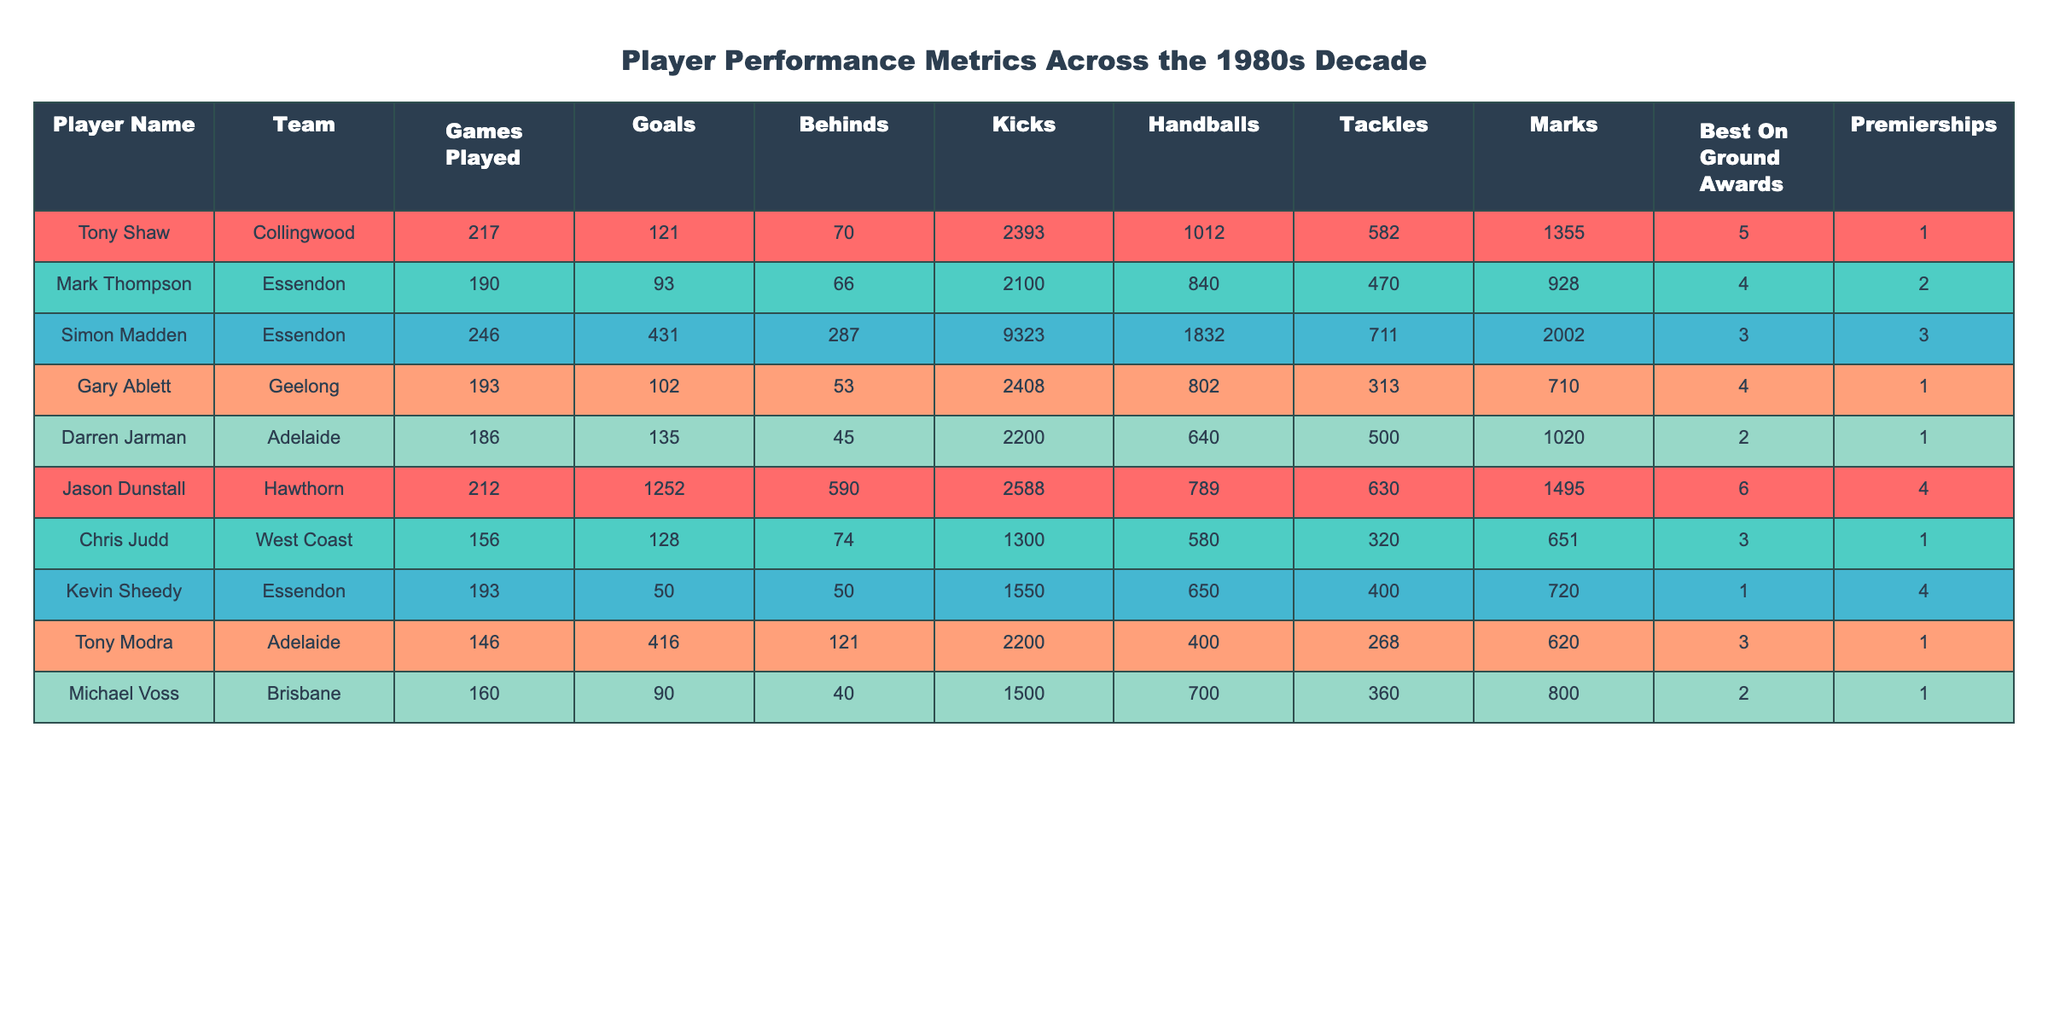What is the player name with the highest number of goals? By checking the "Goals" column, we see that Simon Madden has 431 goals, which is more than any other player listed in the table.
Answer: Simon Madden How many premierships did Mark Thompson win? Looking at the "Premierships" column for Mark Thompson, the value is 2.
Answer: 2 Who has the most games played and how many games did they play? Simon Madden has the highest number of games played, which is 246, as seen in the "Games Played" column.
Answer: Simon Madden, 246 Calculate the average number of Best On Ground Awards won by the players in the table. To find the average, sum the "Best On Ground Awards" (5 + 4 + 3 + 4 + 2 + 6 + 3 + 1 + 3 + 2 = 33) and divide by the number of players (10). Therefore, the average is 33/10 = 3.3.
Answer: 3.3 Is it true that Jason Dunstall won more Best On Ground Awards than Kevin Sheedy? Jason Dunstall has 6 Best On Ground Awards while Kevin Sheedy has only 1. Since 6 is greater than 1, this statement is true.
Answer: Yes How many total goals were scored by players from Essendon? From the table, Mark Thompson scored 93 goals and Simon Madden scored 431 goals. Adding these gives 93 + 431 = 524 total goals scored by Essendon players.
Answer: 524 Which player has the lowest number of marks, and what is their number? Looking at the "Marks" column, Kevin Sheedy has the lowest number of marks with a value of 720, which can be confirmed by comparing all player values in that column.
Answer: Kevin Sheedy, 720 Did Darren Jarman score more goals than Michael Voss? Darren Jarman scored 135 goals while Michael Voss scored 90. Since 135 is greater than 90, this statement is true.
Answer: Yes What is the total number of goals and behinds scored by Tony Modra? Tony Modra scored 416 goals and 121 behinds. Adding these two values gives a total of 416 + 121 = 537.
Answer: 537 